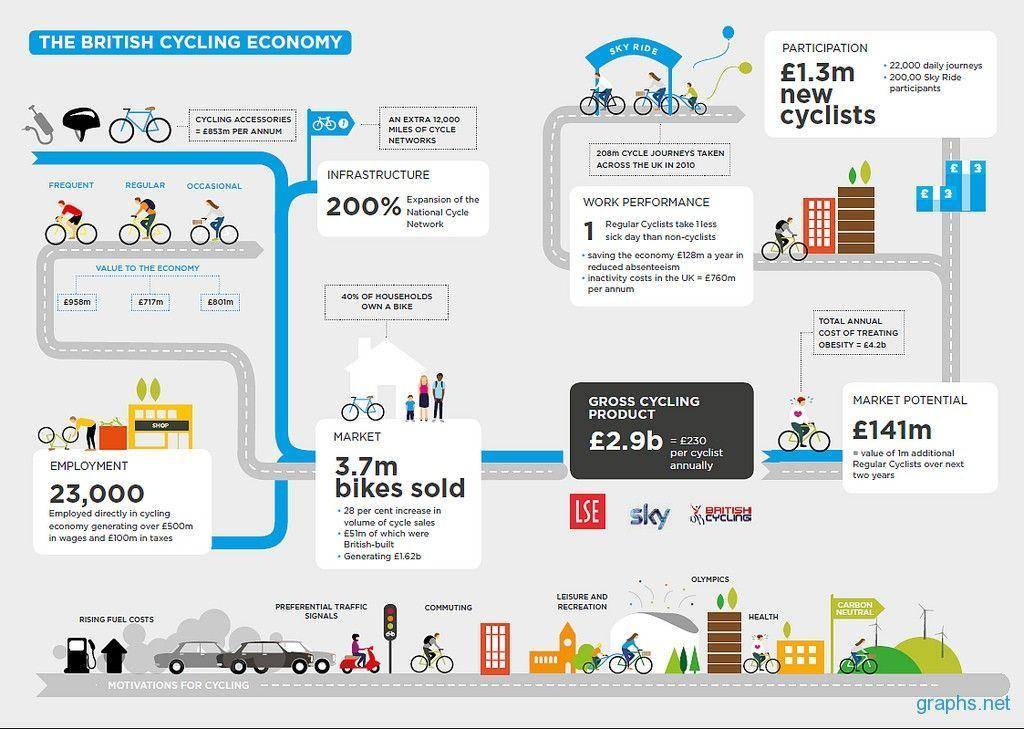Who show better performance at work - regular cyclists or non-cyclists?
Answer the question with a short phrase. regular cyclists How many people are employed in the cycling economy? 23,000 